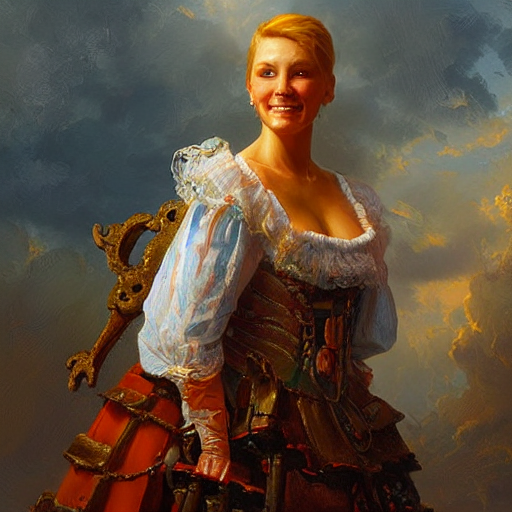What is the condition of the lighting in the image? A. Strong B. Bright C. Weak The lighting in the image appears to be bright, as it highlights the subject's features and clothing, creating a cheerful and vibrant atmosphere. The light sources seem to be off-camera, illuminating the scene effectively without creating harsh shadows, which indicates that the correct answer is B. Bright. 